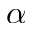<formula> <loc_0><loc_0><loc_500><loc_500>\alpha</formula> 